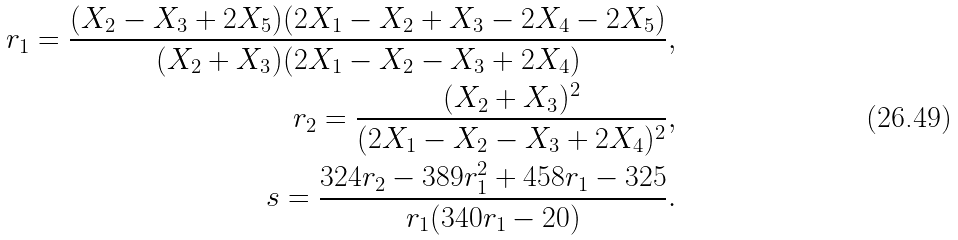Convert formula to latex. <formula><loc_0><loc_0><loc_500><loc_500>r _ { 1 } = \frac { ( X _ { 2 } - X _ { 3 } + 2 X _ { 5 } ) ( 2 X _ { 1 } - X _ { 2 } + X _ { 3 } - 2 X _ { 4 } - 2 X _ { 5 } ) } { ( X _ { 2 } + X _ { 3 } ) ( 2 X _ { 1 } - X _ { 2 } - X _ { 3 } + 2 X _ { 4 } ) } , \\ r _ { 2 } = \frac { ( X _ { 2 } + X _ { 3 } ) ^ { 2 } } { ( 2 X _ { 1 } - X _ { 2 } - X _ { 3 } + 2 X _ { 4 } ) ^ { 2 } } , \\ s = \frac { 3 2 4 r _ { 2 } - 3 8 9 r _ { 1 } ^ { 2 } + 4 5 8 r _ { 1 } - 3 2 5 } { r _ { 1 } ( 3 4 0 r _ { 1 } - 2 0 ) } .</formula> 